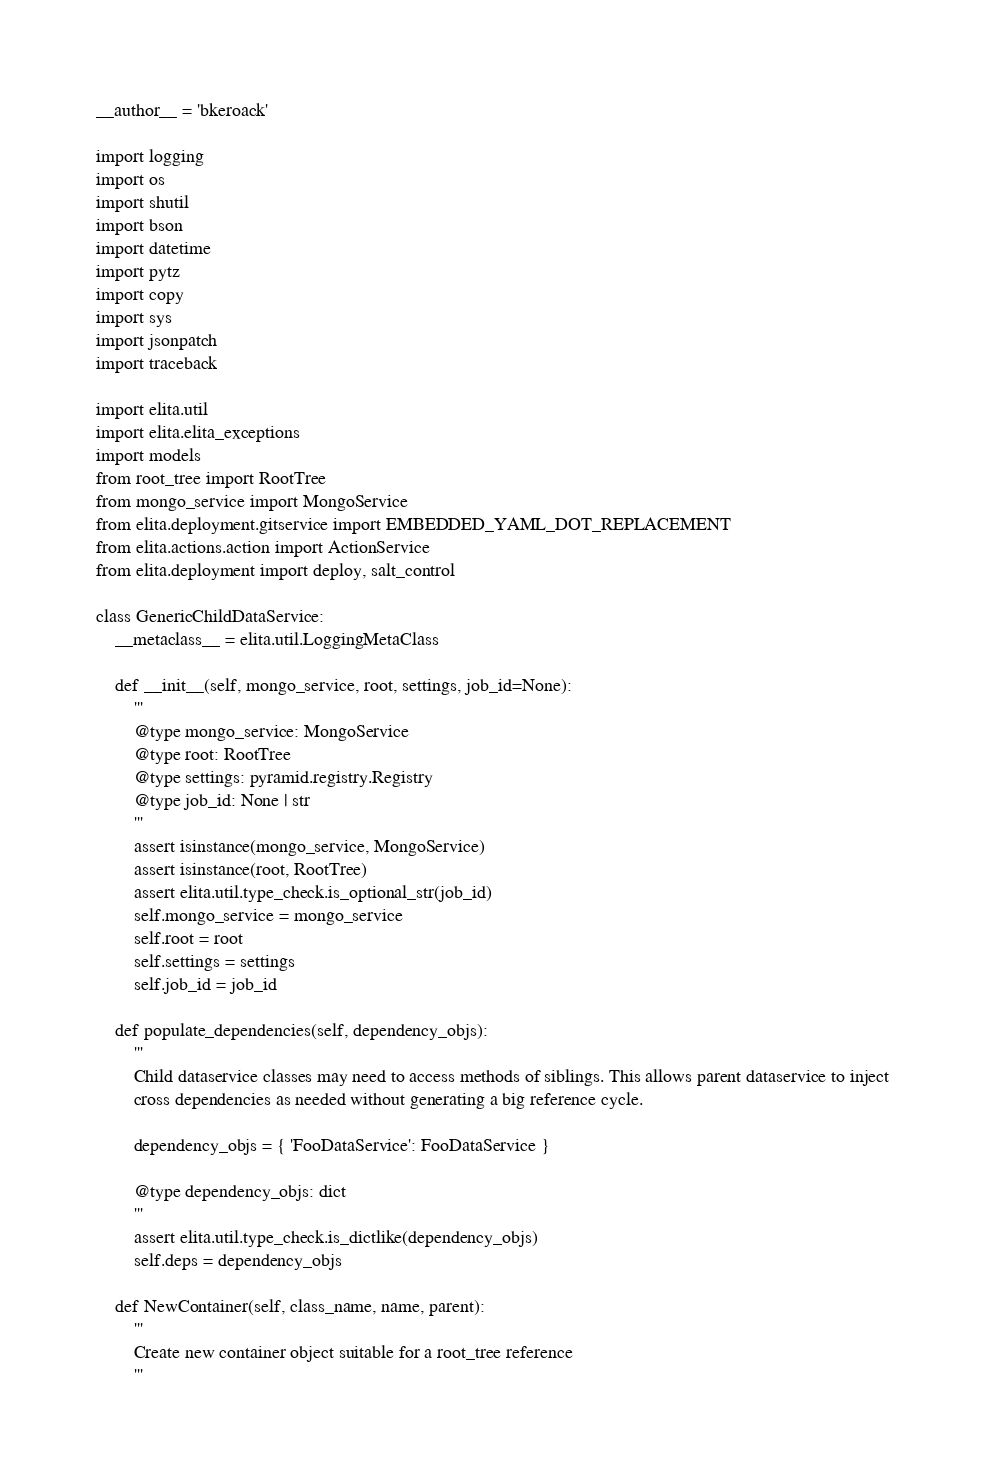Convert code to text. <code><loc_0><loc_0><loc_500><loc_500><_Python_>__author__ = 'bkeroack'

import logging
import os
import shutil
import bson
import datetime
import pytz
import copy
import sys
import jsonpatch
import traceback

import elita.util
import elita.elita_exceptions
import models
from root_tree import RootTree
from mongo_service import MongoService
from elita.deployment.gitservice import EMBEDDED_YAML_DOT_REPLACEMENT
from elita.actions.action import ActionService
from elita.deployment import deploy, salt_control

class GenericChildDataService:
    __metaclass__ = elita.util.LoggingMetaClass

    def __init__(self, mongo_service, root, settings, job_id=None):
        '''
        @type mongo_service: MongoService
        @type root: RootTree
        @type settings: pyramid.registry.Registry
        @type job_id: None | str
        '''
        assert isinstance(mongo_service, MongoService)
        assert isinstance(root, RootTree)
        assert elita.util.type_check.is_optional_str(job_id)
        self.mongo_service = mongo_service
        self.root = root
        self.settings = settings
        self.job_id = job_id

    def populate_dependencies(self, dependency_objs):
        '''
        Child dataservice classes may need to access methods of siblings. This allows parent dataservice to inject
        cross dependencies as needed without generating a big reference cycle.

        dependency_objs = { 'FooDataService': FooDataService }

        @type dependency_objs: dict
        '''
        assert elita.util.type_check.is_dictlike(dependency_objs)
        self.deps = dependency_objs

    def NewContainer(self, class_name, name, parent):
        '''
        Create new container object suitable for a root_tree reference
        '''</code> 